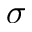Convert formula to latex. <formula><loc_0><loc_0><loc_500><loc_500>\sigma</formula> 